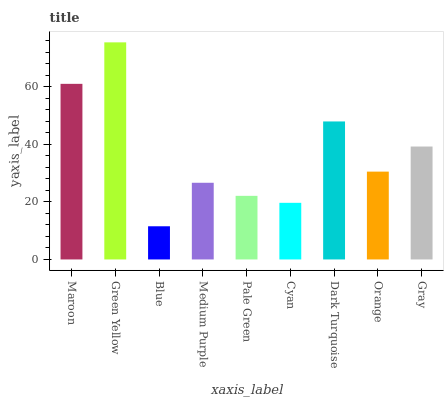Is Green Yellow the maximum?
Answer yes or no. Yes. Is Green Yellow the minimum?
Answer yes or no. No. Is Blue the maximum?
Answer yes or no. No. Is Green Yellow greater than Blue?
Answer yes or no. Yes. Is Blue less than Green Yellow?
Answer yes or no. Yes. Is Blue greater than Green Yellow?
Answer yes or no. No. Is Green Yellow less than Blue?
Answer yes or no. No. Is Orange the high median?
Answer yes or no. Yes. Is Orange the low median?
Answer yes or no. Yes. Is Cyan the high median?
Answer yes or no. No. Is Maroon the low median?
Answer yes or no. No. 